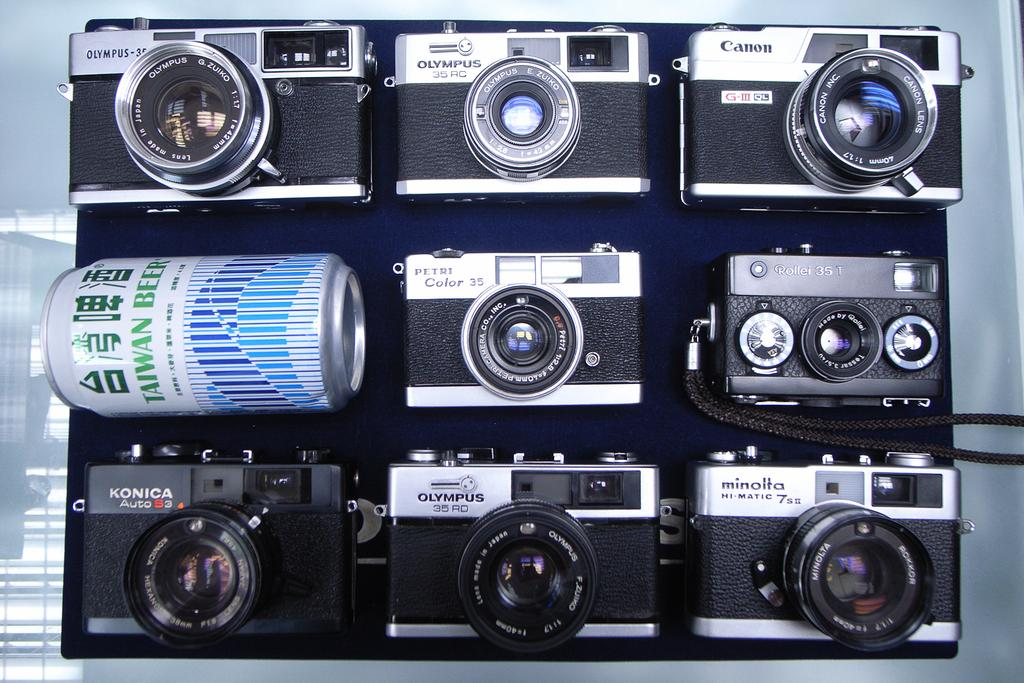What type of equipment is visible in the image? There are cameras in the image. What other object can be seen in the image besides the cameras? There is a tin in the image. What decision is being made by the gate in the image? There is no gate present in the image, so no decision is being made. 